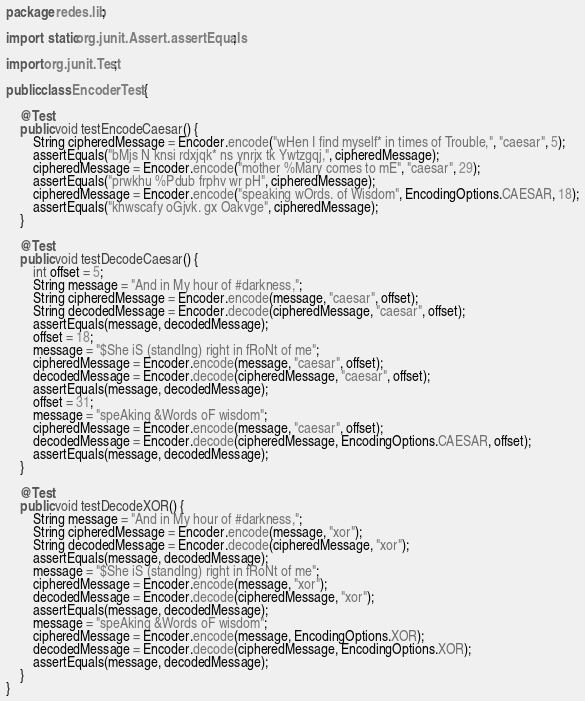Convert code to text. <code><loc_0><loc_0><loc_500><loc_500><_Java_>package redes.lib;

import static org.junit.Assert.assertEquals;

import org.junit.Test;

public class EncoderTest {

    @Test
    public void testEncodeCaesar() {
        String cipheredMessage = Encoder.encode("wHen I find myself* in times of Trouble,", "caesar", 5);
        assertEquals("bMjs N knsi rdxjqk* ns ynrjx tk Ywtzgqj,", cipheredMessage);
        cipheredMessage = Encoder.encode("mother %Mary comes to mE", "caesar", 29);
        assertEquals("prwkhu %Pdub frphv wr pH", cipheredMessage);
        cipheredMessage = Encoder.encode("speaking wOrds. of Wisdom", EncodingOptions.CAESAR, 18);
        assertEquals("khwscafy oGjvk. gx Oakvge", cipheredMessage);
    }

    @Test
    public void testDecodeCaesar() {
        int offset = 5;
        String message = "And in My hour of #darkness,";
        String cipheredMessage = Encoder.encode(message, "caesar", offset);
        String decodedMessage = Encoder.decode(cipheredMessage, "caesar", offset);
        assertEquals(message, decodedMessage);
        offset = 18;
        message = "$She iS (standIng) right in fRoNt of me";
        cipheredMessage = Encoder.encode(message, "caesar", offset);
        decodedMessage = Encoder.decode(cipheredMessage, "caesar", offset);
        assertEquals(message, decodedMessage);
        offset = 31;
        message = "speAking &Words oF wisdom";
        cipheredMessage = Encoder.encode(message, "caesar", offset);
        decodedMessage = Encoder.decode(cipheredMessage, EncodingOptions.CAESAR, offset);
        assertEquals(message, decodedMessage);
    }

    @Test
    public void testDecodeXOR() {
        String message = "And in My hour of #darkness,";
        String cipheredMessage = Encoder.encode(message, "xor");
        String decodedMessage = Encoder.decode(cipheredMessage, "xor");
        assertEquals(message, decodedMessage);
        message = "$She iS (standIng) right in fRoNt of me";
        cipheredMessage = Encoder.encode(message, "xor");
        decodedMessage = Encoder.decode(cipheredMessage, "xor");
        assertEquals(message, decodedMessage);
        message = "speAking &Words oF wisdom";
        cipheredMessage = Encoder.encode(message, EncodingOptions.XOR);
        decodedMessage = Encoder.decode(cipheredMessage, EncodingOptions.XOR);
        assertEquals(message, decodedMessage);
    }
}
</code> 